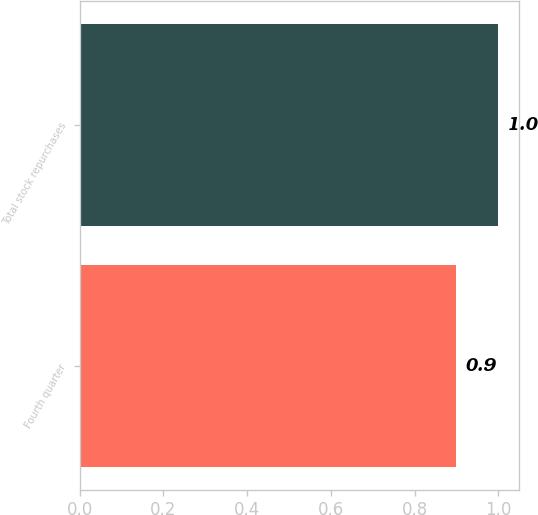Convert chart. <chart><loc_0><loc_0><loc_500><loc_500><bar_chart><fcel>Fourth quarter<fcel>Total stock repurchases<nl><fcel>0.9<fcel>1<nl></chart> 